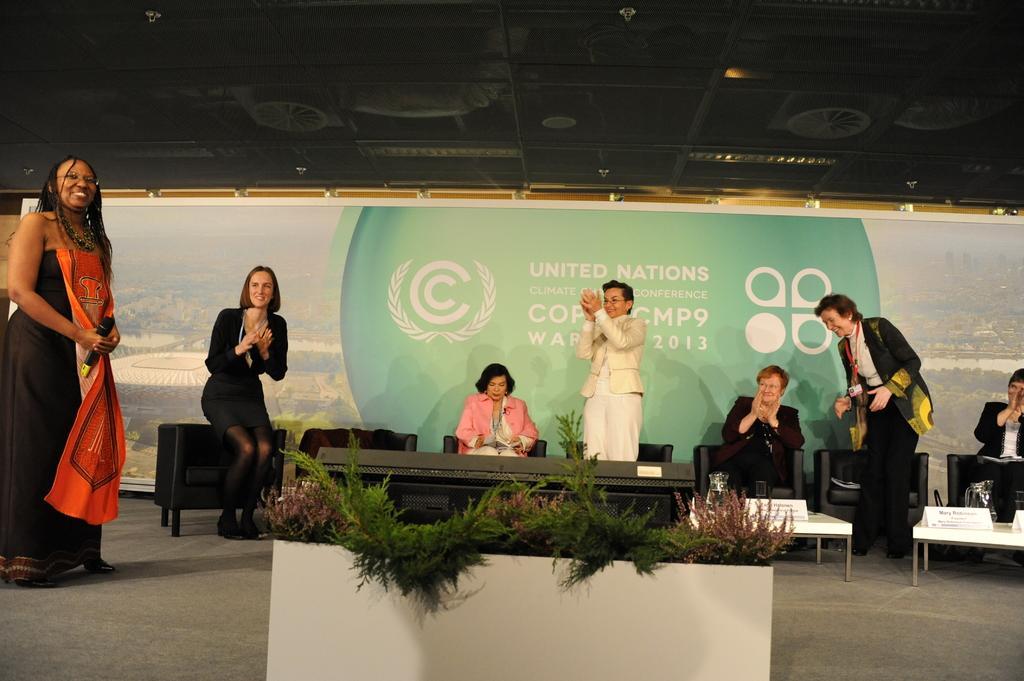How would you summarize this image in a sentence or two? In this picture there are three people standing and clapping and there are three people sitting on the chairs and there are chairs and tables and there are jugs and boards on the tables. In the foreground there is a plant. On the left side of the image there is a woman standing and holding the microphone. At the back there is a board and there is text on the board. At the top there are lights. At the bottom there is a floor. 